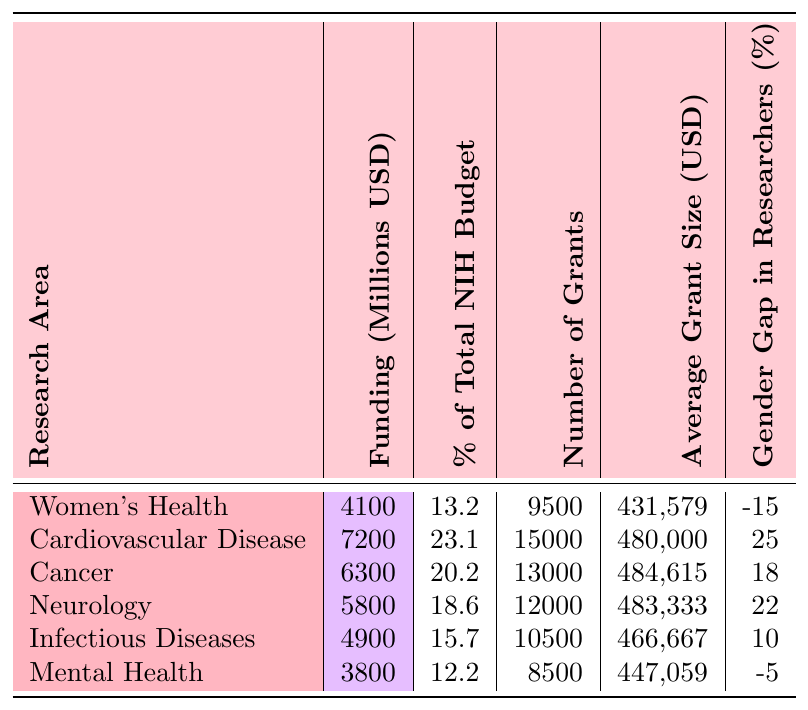What is the total funding allocated for women's health research? The table shows that the funding allocated for women's health research is 4100 million USD.
Answer: 4100 million USD What percentage of the total NIH budget is allocated to cancer research? Referring to the table, cancer research is allocated 20.2% of the total NIH budget.
Answer: 20.2% How many grants were awarded for neurology research? According to the table, there are 12,000 grants awarded for neurology research.
Answer: 12,000 What is the average grant size for infectious diseases research? The average grant size for infectious diseases research, as per the table, is 466,667 USD.
Answer: 466,667 USD Which research area has the highest funding allocation? The table indicates that cardiovascular disease has the highest funding allocation at 7200 million USD.
Answer: Cardiovascular Disease Which research area has the most number of grants awarded? The table reveals that cardiovascular disease also has the most number of grants awarded, totaling 15,000.
Answer: Cardiovascular Disease What is the funding difference between cancer and neurology research? The funding for cancer is 6300 million USD, and for neurology, it's 5800 million USD. The difference is 6300 - 5800 = 500 million USD.
Answer: 500 million USD Is the gender gap in researchers for women's health positive or negative? According to the table, the gender gap for women's health is -15%, indicating it is negative.
Answer: Negative What is the average grant size for women's health compared to mental health? Women's health has an average grant size of 431,579 USD, while mental health has 447,059 USD. Comparing them, women's health is smaller by 447,059 - 431,579 = 15,480 USD.
Answer: Women's health is smaller by 15,480 USD Which area has a more significant gender gap in researchers, cancer or infectious diseases? The gender gap in cancer is 18%, and in infectious diseases, it is 10%. Since 18% is greater, cancer has a more significant gender gap.
Answer: Cancer 